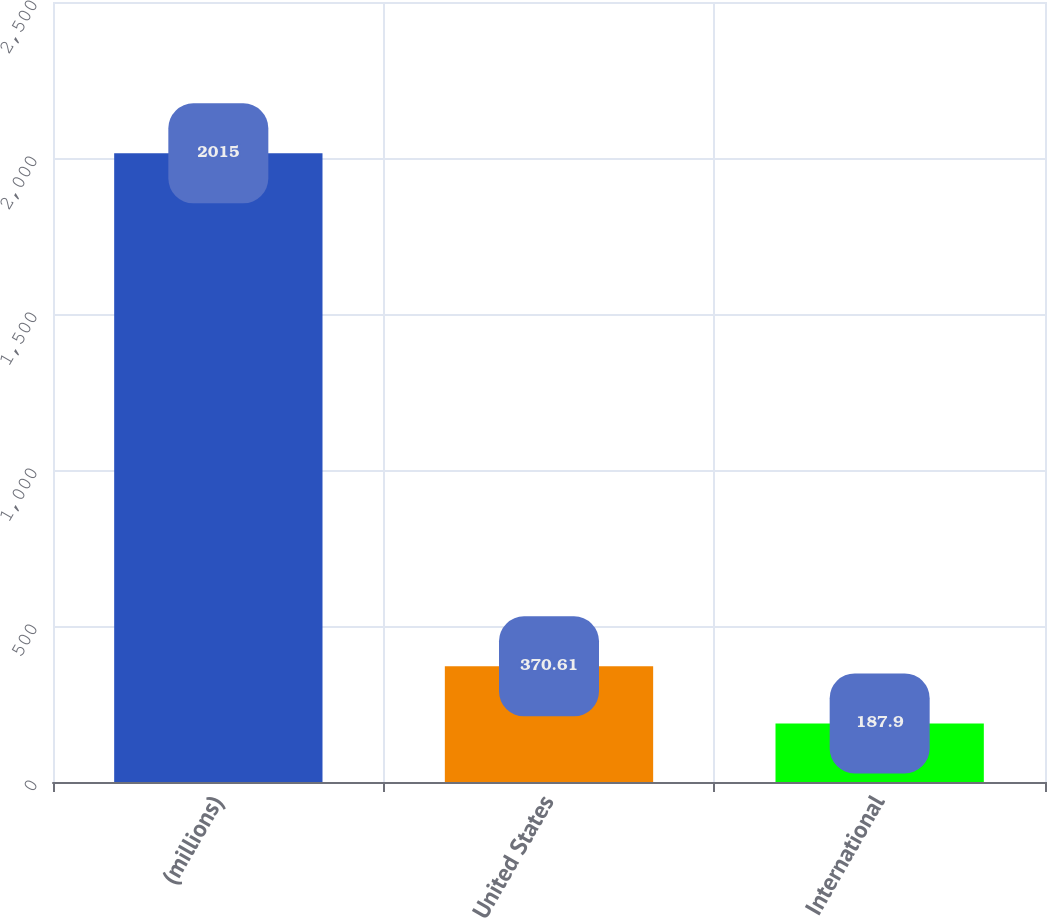Convert chart. <chart><loc_0><loc_0><loc_500><loc_500><bar_chart><fcel>(millions)<fcel>United States<fcel>International<nl><fcel>2015<fcel>370.61<fcel>187.9<nl></chart> 